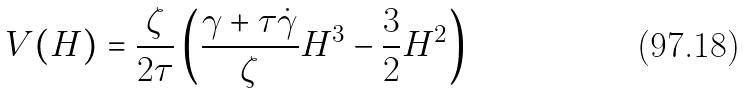Convert formula to latex. <formula><loc_0><loc_0><loc_500><loc_500>V ( H ) = \frac { \zeta } { 2 \tau } \left ( \frac { \gamma + \tau \dot { \gamma } } { \zeta } H ^ { 3 } - \frac { 3 } { 2 } H ^ { 2 } \right )</formula> 